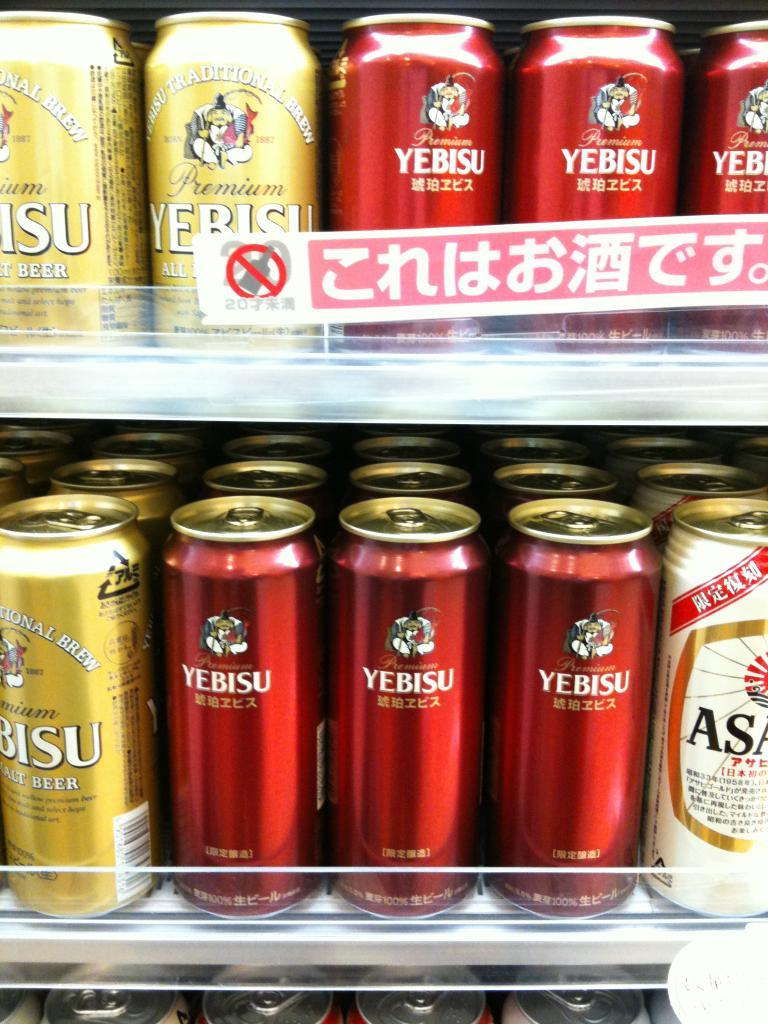<image>
Offer a succinct explanation of the picture presented. some cans with some that says Yebisu on it 